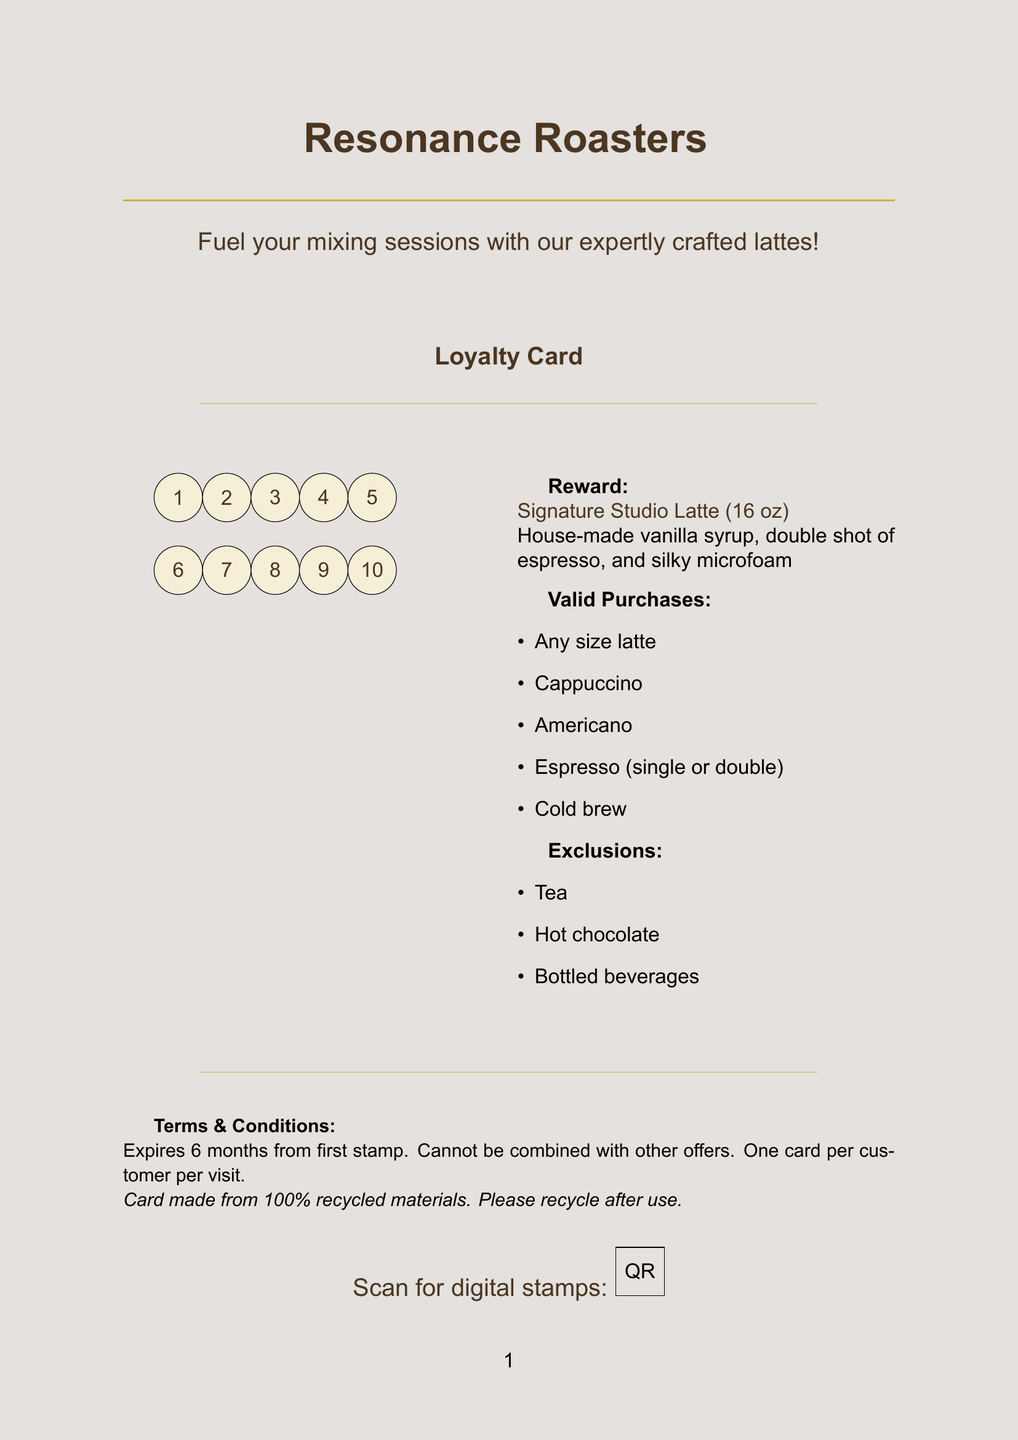What is the name of the coffee shop? The name of the coffee shop is mentioned prominently at the top of the document.
Answer: Resonance Roasters What is the size of the reward drink? The size of the reward drink is specified in the reward section of the document.
Answer: 16 oz How many stamp spaces are there? The total number of stamp spaces is indicated in the loyalty card section of the document.
Answer: 10 What type of material is the punch card made from? The material of the punch card is stated in the card design section.
Answer: Thick, textured cardstock What is the expiration period of the card? The expiration period for the card can be found in the terms and conditions section.
Answer: 6 months from first stamp Which drink is excluded from the reward program? The exclusions list mentions drinks that are not eligible for rewards.
Answer: Tea What is the special feature of the punch card? The document includes a special feature that allows for additional functionality.
Answer: QR code for digital stamp collection option Which drink can you buy to earn a stamp on the card? Valid purchases are listed, and one is chosen as an example for earning stamps.
Answer: Any size latte What information is included in the contact details? The contact details section provides specific information about how to reach the coffee shop.
Answer: Phone, website, address 